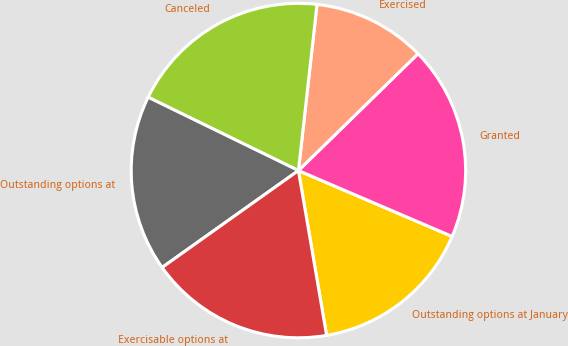Convert chart. <chart><loc_0><loc_0><loc_500><loc_500><pie_chart><fcel>Outstanding options at January<fcel>Granted<fcel>Exercised<fcel>Canceled<fcel>Outstanding options at<fcel>Exercisable options at<nl><fcel>15.86%<fcel>18.76%<fcel>10.91%<fcel>19.55%<fcel>17.06%<fcel>17.86%<nl></chart> 